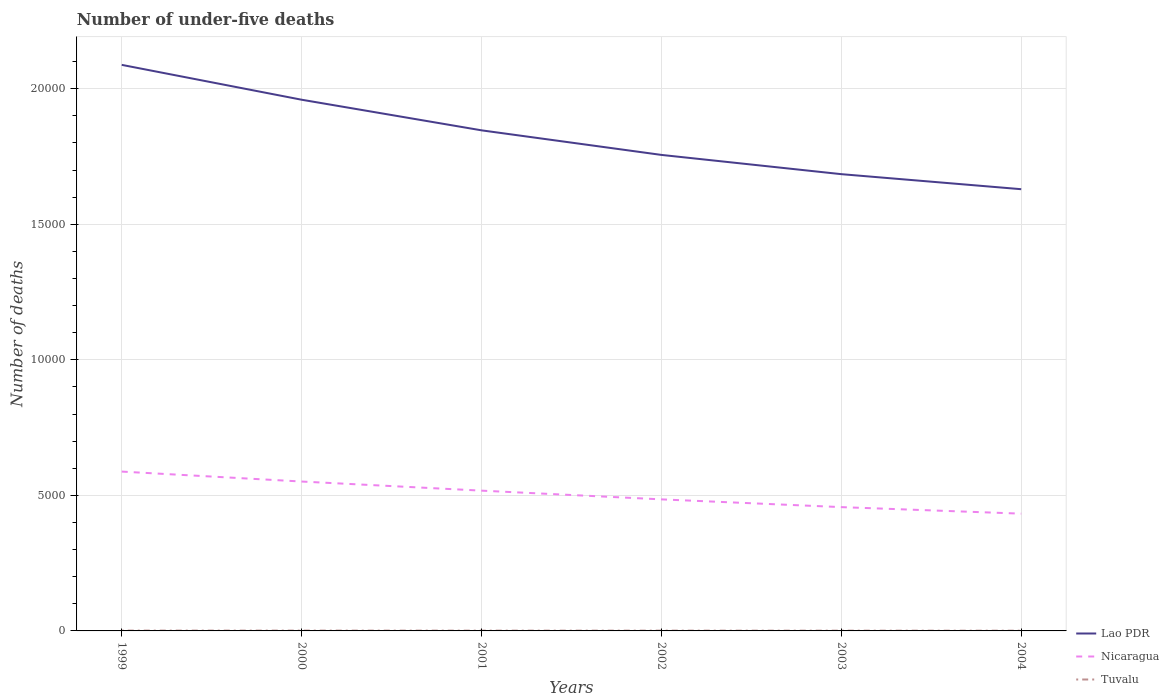Is the number of lines equal to the number of legend labels?
Provide a short and direct response. Yes. Across all years, what is the maximum number of under-five deaths in Lao PDR?
Keep it short and to the point. 1.63e+04. In which year was the number of under-five deaths in Nicaragua maximum?
Make the answer very short. 2004. What is the total number of under-five deaths in Lao PDR in the graph?
Offer a very short reply. 3322. Is the number of under-five deaths in Tuvalu strictly greater than the number of under-five deaths in Lao PDR over the years?
Your answer should be very brief. Yes. How many years are there in the graph?
Keep it short and to the point. 6. What is the difference between two consecutive major ticks on the Y-axis?
Give a very brief answer. 5000. Are the values on the major ticks of Y-axis written in scientific E-notation?
Your response must be concise. No. Does the graph contain any zero values?
Ensure brevity in your answer.  No. How many legend labels are there?
Your answer should be very brief. 3. What is the title of the graph?
Your answer should be very brief. Number of under-five deaths. What is the label or title of the X-axis?
Offer a very short reply. Years. What is the label or title of the Y-axis?
Make the answer very short. Number of deaths. What is the Number of deaths of Lao PDR in 1999?
Provide a short and direct response. 2.09e+04. What is the Number of deaths in Nicaragua in 1999?
Ensure brevity in your answer.  5878. What is the Number of deaths of Tuvalu in 1999?
Provide a succinct answer. 12. What is the Number of deaths in Lao PDR in 2000?
Your response must be concise. 1.96e+04. What is the Number of deaths in Nicaragua in 2000?
Offer a terse response. 5511. What is the Number of deaths of Lao PDR in 2001?
Offer a terse response. 1.85e+04. What is the Number of deaths of Nicaragua in 2001?
Your answer should be very brief. 5175. What is the Number of deaths in Lao PDR in 2002?
Provide a short and direct response. 1.76e+04. What is the Number of deaths in Nicaragua in 2002?
Provide a succinct answer. 4853. What is the Number of deaths of Tuvalu in 2002?
Provide a short and direct response. 11. What is the Number of deaths of Lao PDR in 2003?
Your answer should be compact. 1.68e+04. What is the Number of deaths of Nicaragua in 2003?
Make the answer very short. 4567. What is the Number of deaths of Lao PDR in 2004?
Your response must be concise. 1.63e+04. What is the Number of deaths of Nicaragua in 2004?
Your response must be concise. 4326. What is the Number of deaths of Tuvalu in 2004?
Provide a short and direct response. 9. Across all years, what is the maximum Number of deaths in Lao PDR?
Your answer should be compact. 2.09e+04. Across all years, what is the maximum Number of deaths in Nicaragua?
Your answer should be very brief. 5878. Across all years, what is the maximum Number of deaths of Tuvalu?
Provide a succinct answer. 12. Across all years, what is the minimum Number of deaths of Lao PDR?
Your response must be concise. 1.63e+04. Across all years, what is the minimum Number of deaths in Nicaragua?
Provide a succinct answer. 4326. What is the total Number of deaths of Lao PDR in the graph?
Make the answer very short. 1.10e+05. What is the total Number of deaths in Nicaragua in the graph?
Provide a short and direct response. 3.03e+04. What is the total Number of deaths in Tuvalu in the graph?
Your answer should be very brief. 65. What is the difference between the Number of deaths of Lao PDR in 1999 and that in 2000?
Provide a short and direct response. 1286. What is the difference between the Number of deaths of Nicaragua in 1999 and that in 2000?
Your answer should be very brief. 367. What is the difference between the Number of deaths in Tuvalu in 1999 and that in 2000?
Provide a succinct answer. 0. What is the difference between the Number of deaths in Lao PDR in 1999 and that in 2001?
Give a very brief answer. 2415. What is the difference between the Number of deaths in Nicaragua in 1999 and that in 2001?
Your answer should be compact. 703. What is the difference between the Number of deaths of Tuvalu in 1999 and that in 2001?
Ensure brevity in your answer.  1. What is the difference between the Number of deaths in Lao PDR in 1999 and that in 2002?
Provide a succinct answer. 3322. What is the difference between the Number of deaths in Nicaragua in 1999 and that in 2002?
Give a very brief answer. 1025. What is the difference between the Number of deaths in Lao PDR in 1999 and that in 2003?
Offer a very short reply. 4032. What is the difference between the Number of deaths of Nicaragua in 1999 and that in 2003?
Your answer should be compact. 1311. What is the difference between the Number of deaths of Lao PDR in 1999 and that in 2004?
Ensure brevity in your answer.  4587. What is the difference between the Number of deaths in Nicaragua in 1999 and that in 2004?
Make the answer very short. 1552. What is the difference between the Number of deaths in Lao PDR in 2000 and that in 2001?
Your answer should be compact. 1129. What is the difference between the Number of deaths of Nicaragua in 2000 and that in 2001?
Make the answer very short. 336. What is the difference between the Number of deaths in Tuvalu in 2000 and that in 2001?
Your response must be concise. 1. What is the difference between the Number of deaths of Lao PDR in 2000 and that in 2002?
Offer a very short reply. 2036. What is the difference between the Number of deaths of Nicaragua in 2000 and that in 2002?
Your answer should be compact. 658. What is the difference between the Number of deaths in Lao PDR in 2000 and that in 2003?
Provide a succinct answer. 2746. What is the difference between the Number of deaths in Nicaragua in 2000 and that in 2003?
Keep it short and to the point. 944. What is the difference between the Number of deaths of Lao PDR in 2000 and that in 2004?
Your response must be concise. 3301. What is the difference between the Number of deaths in Nicaragua in 2000 and that in 2004?
Ensure brevity in your answer.  1185. What is the difference between the Number of deaths in Tuvalu in 2000 and that in 2004?
Keep it short and to the point. 3. What is the difference between the Number of deaths in Lao PDR in 2001 and that in 2002?
Your answer should be very brief. 907. What is the difference between the Number of deaths in Nicaragua in 2001 and that in 2002?
Provide a succinct answer. 322. What is the difference between the Number of deaths in Tuvalu in 2001 and that in 2002?
Provide a short and direct response. 0. What is the difference between the Number of deaths in Lao PDR in 2001 and that in 2003?
Offer a very short reply. 1617. What is the difference between the Number of deaths in Nicaragua in 2001 and that in 2003?
Your answer should be very brief. 608. What is the difference between the Number of deaths in Tuvalu in 2001 and that in 2003?
Ensure brevity in your answer.  1. What is the difference between the Number of deaths in Lao PDR in 2001 and that in 2004?
Keep it short and to the point. 2172. What is the difference between the Number of deaths in Nicaragua in 2001 and that in 2004?
Provide a short and direct response. 849. What is the difference between the Number of deaths in Tuvalu in 2001 and that in 2004?
Your response must be concise. 2. What is the difference between the Number of deaths in Lao PDR in 2002 and that in 2003?
Make the answer very short. 710. What is the difference between the Number of deaths of Nicaragua in 2002 and that in 2003?
Keep it short and to the point. 286. What is the difference between the Number of deaths of Tuvalu in 2002 and that in 2003?
Make the answer very short. 1. What is the difference between the Number of deaths in Lao PDR in 2002 and that in 2004?
Provide a short and direct response. 1265. What is the difference between the Number of deaths of Nicaragua in 2002 and that in 2004?
Keep it short and to the point. 527. What is the difference between the Number of deaths of Tuvalu in 2002 and that in 2004?
Your answer should be very brief. 2. What is the difference between the Number of deaths of Lao PDR in 2003 and that in 2004?
Your answer should be compact. 555. What is the difference between the Number of deaths in Nicaragua in 2003 and that in 2004?
Provide a succinct answer. 241. What is the difference between the Number of deaths in Tuvalu in 2003 and that in 2004?
Offer a terse response. 1. What is the difference between the Number of deaths of Lao PDR in 1999 and the Number of deaths of Nicaragua in 2000?
Your response must be concise. 1.54e+04. What is the difference between the Number of deaths in Lao PDR in 1999 and the Number of deaths in Tuvalu in 2000?
Offer a terse response. 2.09e+04. What is the difference between the Number of deaths of Nicaragua in 1999 and the Number of deaths of Tuvalu in 2000?
Your answer should be compact. 5866. What is the difference between the Number of deaths in Lao PDR in 1999 and the Number of deaths in Nicaragua in 2001?
Your response must be concise. 1.57e+04. What is the difference between the Number of deaths in Lao PDR in 1999 and the Number of deaths in Tuvalu in 2001?
Provide a short and direct response. 2.09e+04. What is the difference between the Number of deaths of Nicaragua in 1999 and the Number of deaths of Tuvalu in 2001?
Your answer should be compact. 5867. What is the difference between the Number of deaths of Lao PDR in 1999 and the Number of deaths of Nicaragua in 2002?
Provide a succinct answer. 1.60e+04. What is the difference between the Number of deaths of Lao PDR in 1999 and the Number of deaths of Tuvalu in 2002?
Offer a very short reply. 2.09e+04. What is the difference between the Number of deaths of Nicaragua in 1999 and the Number of deaths of Tuvalu in 2002?
Your answer should be very brief. 5867. What is the difference between the Number of deaths in Lao PDR in 1999 and the Number of deaths in Nicaragua in 2003?
Provide a succinct answer. 1.63e+04. What is the difference between the Number of deaths in Lao PDR in 1999 and the Number of deaths in Tuvalu in 2003?
Offer a very short reply. 2.09e+04. What is the difference between the Number of deaths of Nicaragua in 1999 and the Number of deaths of Tuvalu in 2003?
Offer a very short reply. 5868. What is the difference between the Number of deaths in Lao PDR in 1999 and the Number of deaths in Nicaragua in 2004?
Provide a short and direct response. 1.66e+04. What is the difference between the Number of deaths in Lao PDR in 1999 and the Number of deaths in Tuvalu in 2004?
Offer a terse response. 2.09e+04. What is the difference between the Number of deaths in Nicaragua in 1999 and the Number of deaths in Tuvalu in 2004?
Your answer should be very brief. 5869. What is the difference between the Number of deaths in Lao PDR in 2000 and the Number of deaths in Nicaragua in 2001?
Your response must be concise. 1.44e+04. What is the difference between the Number of deaths in Lao PDR in 2000 and the Number of deaths in Tuvalu in 2001?
Keep it short and to the point. 1.96e+04. What is the difference between the Number of deaths of Nicaragua in 2000 and the Number of deaths of Tuvalu in 2001?
Your answer should be compact. 5500. What is the difference between the Number of deaths of Lao PDR in 2000 and the Number of deaths of Nicaragua in 2002?
Ensure brevity in your answer.  1.47e+04. What is the difference between the Number of deaths in Lao PDR in 2000 and the Number of deaths in Tuvalu in 2002?
Give a very brief answer. 1.96e+04. What is the difference between the Number of deaths in Nicaragua in 2000 and the Number of deaths in Tuvalu in 2002?
Offer a terse response. 5500. What is the difference between the Number of deaths in Lao PDR in 2000 and the Number of deaths in Nicaragua in 2003?
Keep it short and to the point. 1.50e+04. What is the difference between the Number of deaths in Lao PDR in 2000 and the Number of deaths in Tuvalu in 2003?
Offer a very short reply. 1.96e+04. What is the difference between the Number of deaths in Nicaragua in 2000 and the Number of deaths in Tuvalu in 2003?
Your answer should be very brief. 5501. What is the difference between the Number of deaths of Lao PDR in 2000 and the Number of deaths of Nicaragua in 2004?
Ensure brevity in your answer.  1.53e+04. What is the difference between the Number of deaths in Lao PDR in 2000 and the Number of deaths in Tuvalu in 2004?
Make the answer very short. 1.96e+04. What is the difference between the Number of deaths in Nicaragua in 2000 and the Number of deaths in Tuvalu in 2004?
Offer a terse response. 5502. What is the difference between the Number of deaths of Lao PDR in 2001 and the Number of deaths of Nicaragua in 2002?
Provide a succinct answer. 1.36e+04. What is the difference between the Number of deaths of Lao PDR in 2001 and the Number of deaths of Tuvalu in 2002?
Offer a very short reply. 1.85e+04. What is the difference between the Number of deaths in Nicaragua in 2001 and the Number of deaths in Tuvalu in 2002?
Offer a terse response. 5164. What is the difference between the Number of deaths of Lao PDR in 2001 and the Number of deaths of Nicaragua in 2003?
Offer a terse response. 1.39e+04. What is the difference between the Number of deaths of Lao PDR in 2001 and the Number of deaths of Tuvalu in 2003?
Your answer should be very brief. 1.85e+04. What is the difference between the Number of deaths of Nicaragua in 2001 and the Number of deaths of Tuvalu in 2003?
Your answer should be very brief. 5165. What is the difference between the Number of deaths in Lao PDR in 2001 and the Number of deaths in Nicaragua in 2004?
Offer a terse response. 1.41e+04. What is the difference between the Number of deaths in Lao PDR in 2001 and the Number of deaths in Tuvalu in 2004?
Give a very brief answer. 1.85e+04. What is the difference between the Number of deaths in Nicaragua in 2001 and the Number of deaths in Tuvalu in 2004?
Ensure brevity in your answer.  5166. What is the difference between the Number of deaths of Lao PDR in 2002 and the Number of deaths of Nicaragua in 2003?
Your response must be concise. 1.30e+04. What is the difference between the Number of deaths of Lao PDR in 2002 and the Number of deaths of Tuvalu in 2003?
Make the answer very short. 1.76e+04. What is the difference between the Number of deaths of Nicaragua in 2002 and the Number of deaths of Tuvalu in 2003?
Provide a succinct answer. 4843. What is the difference between the Number of deaths in Lao PDR in 2002 and the Number of deaths in Nicaragua in 2004?
Your answer should be very brief. 1.32e+04. What is the difference between the Number of deaths of Lao PDR in 2002 and the Number of deaths of Tuvalu in 2004?
Make the answer very short. 1.76e+04. What is the difference between the Number of deaths in Nicaragua in 2002 and the Number of deaths in Tuvalu in 2004?
Your response must be concise. 4844. What is the difference between the Number of deaths in Lao PDR in 2003 and the Number of deaths in Nicaragua in 2004?
Provide a short and direct response. 1.25e+04. What is the difference between the Number of deaths of Lao PDR in 2003 and the Number of deaths of Tuvalu in 2004?
Give a very brief answer. 1.68e+04. What is the difference between the Number of deaths in Nicaragua in 2003 and the Number of deaths in Tuvalu in 2004?
Offer a very short reply. 4558. What is the average Number of deaths in Lao PDR per year?
Your response must be concise. 1.83e+04. What is the average Number of deaths of Nicaragua per year?
Make the answer very short. 5051.67. What is the average Number of deaths of Tuvalu per year?
Offer a very short reply. 10.83. In the year 1999, what is the difference between the Number of deaths in Lao PDR and Number of deaths in Nicaragua?
Your answer should be compact. 1.50e+04. In the year 1999, what is the difference between the Number of deaths in Lao PDR and Number of deaths in Tuvalu?
Your answer should be very brief. 2.09e+04. In the year 1999, what is the difference between the Number of deaths in Nicaragua and Number of deaths in Tuvalu?
Make the answer very short. 5866. In the year 2000, what is the difference between the Number of deaths in Lao PDR and Number of deaths in Nicaragua?
Offer a terse response. 1.41e+04. In the year 2000, what is the difference between the Number of deaths in Lao PDR and Number of deaths in Tuvalu?
Make the answer very short. 1.96e+04. In the year 2000, what is the difference between the Number of deaths of Nicaragua and Number of deaths of Tuvalu?
Provide a short and direct response. 5499. In the year 2001, what is the difference between the Number of deaths of Lao PDR and Number of deaths of Nicaragua?
Ensure brevity in your answer.  1.33e+04. In the year 2001, what is the difference between the Number of deaths of Lao PDR and Number of deaths of Tuvalu?
Ensure brevity in your answer.  1.85e+04. In the year 2001, what is the difference between the Number of deaths in Nicaragua and Number of deaths in Tuvalu?
Provide a succinct answer. 5164. In the year 2002, what is the difference between the Number of deaths of Lao PDR and Number of deaths of Nicaragua?
Your answer should be compact. 1.27e+04. In the year 2002, what is the difference between the Number of deaths in Lao PDR and Number of deaths in Tuvalu?
Make the answer very short. 1.75e+04. In the year 2002, what is the difference between the Number of deaths in Nicaragua and Number of deaths in Tuvalu?
Offer a terse response. 4842. In the year 2003, what is the difference between the Number of deaths in Lao PDR and Number of deaths in Nicaragua?
Your answer should be compact. 1.23e+04. In the year 2003, what is the difference between the Number of deaths in Lao PDR and Number of deaths in Tuvalu?
Give a very brief answer. 1.68e+04. In the year 2003, what is the difference between the Number of deaths of Nicaragua and Number of deaths of Tuvalu?
Your answer should be very brief. 4557. In the year 2004, what is the difference between the Number of deaths in Lao PDR and Number of deaths in Nicaragua?
Your answer should be very brief. 1.20e+04. In the year 2004, what is the difference between the Number of deaths of Lao PDR and Number of deaths of Tuvalu?
Keep it short and to the point. 1.63e+04. In the year 2004, what is the difference between the Number of deaths of Nicaragua and Number of deaths of Tuvalu?
Make the answer very short. 4317. What is the ratio of the Number of deaths in Lao PDR in 1999 to that in 2000?
Offer a very short reply. 1.07. What is the ratio of the Number of deaths of Nicaragua in 1999 to that in 2000?
Your answer should be very brief. 1.07. What is the ratio of the Number of deaths in Lao PDR in 1999 to that in 2001?
Provide a short and direct response. 1.13. What is the ratio of the Number of deaths in Nicaragua in 1999 to that in 2001?
Offer a terse response. 1.14. What is the ratio of the Number of deaths in Tuvalu in 1999 to that in 2001?
Keep it short and to the point. 1.09. What is the ratio of the Number of deaths of Lao PDR in 1999 to that in 2002?
Your answer should be very brief. 1.19. What is the ratio of the Number of deaths of Nicaragua in 1999 to that in 2002?
Offer a very short reply. 1.21. What is the ratio of the Number of deaths in Lao PDR in 1999 to that in 2003?
Keep it short and to the point. 1.24. What is the ratio of the Number of deaths of Nicaragua in 1999 to that in 2003?
Keep it short and to the point. 1.29. What is the ratio of the Number of deaths in Tuvalu in 1999 to that in 2003?
Offer a terse response. 1.2. What is the ratio of the Number of deaths in Lao PDR in 1999 to that in 2004?
Your answer should be very brief. 1.28. What is the ratio of the Number of deaths of Nicaragua in 1999 to that in 2004?
Your answer should be compact. 1.36. What is the ratio of the Number of deaths in Lao PDR in 2000 to that in 2001?
Provide a succinct answer. 1.06. What is the ratio of the Number of deaths of Nicaragua in 2000 to that in 2001?
Offer a very short reply. 1.06. What is the ratio of the Number of deaths in Tuvalu in 2000 to that in 2001?
Ensure brevity in your answer.  1.09. What is the ratio of the Number of deaths of Lao PDR in 2000 to that in 2002?
Keep it short and to the point. 1.12. What is the ratio of the Number of deaths of Nicaragua in 2000 to that in 2002?
Your answer should be very brief. 1.14. What is the ratio of the Number of deaths of Lao PDR in 2000 to that in 2003?
Offer a very short reply. 1.16. What is the ratio of the Number of deaths in Nicaragua in 2000 to that in 2003?
Your answer should be very brief. 1.21. What is the ratio of the Number of deaths of Tuvalu in 2000 to that in 2003?
Provide a short and direct response. 1.2. What is the ratio of the Number of deaths of Lao PDR in 2000 to that in 2004?
Ensure brevity in your answer.  1.2. What is the ratio of the Number of deaths of Nicaragua in 2000 to that in 2004?
Offer a very short reply. 1.27. What is the ratio of the Number of deaths in Tuvalu in 2000 to that in 2004?
Your answer should be compact. 1.33. What is the ratio of the Number of deaths of Lao PDR in 2001 to that in 2002?
Keep it short and to the point. 1.05. What is the ratio of the Number of deaths in Nicaragua in 2001 to that in 2002?
Your response must be concise. 1.07. What is the ratio of the Number of deaths in Lao PDR in 2001 to that in 2003?
Give a very brief answer. 1.1. What is the ratio of the Number of deaths of Nicaragua in 2001 to that in 2003?
Keep it short and to the point. 1.13. What is the ratio of the Number of deaths in Lao PDR in 2001 to that in 2004?
Offer a very short reply. 1.13. What is the ratio of the Number of deaths of Nicaragua in 2001 to that in 2004?
Your answer should be compact. 1.2. What is the ratio of the Number of deaths in Tuvalu in 2001 to that in 2004?
Offer a terse response. 1.22. What is the ratio of the Number of deaths in Lao PDR in 2002 to that in 2003?
Keep it short and to the point. 1.04. What is the ratio of the Number of deaths in Nicaragua in 2002 to that in 2003?
Give a very brief answer. 1.06. What is the ratio of the Number of deaths of Tuvalu in 2002 to that in 2003?
Your answer should be very brief. 1.1. What is the ratio of the Number of deaths in Lao PDR in 2002 to that in 2004?
Your answer should be very brief. 1.08. What is the ratio of the Number of deaths in Nicaragua in 2002 to that in 2004?
Provide a short and direct response. 1.12. What is the ratio of the Number of deaths of Tuvalu in 2002 to that in 2004?
Give a very brief answer. 1.22. What is the ratio of the Number of deaths in Lao PDR in 2003 to that in 2004?
Your answer should be compact. 1.03. What is the ratio of the Number of deaths in Nicaragua in 2003 to that in 2004?
Provide a succinct answer. 1.06. What is the difference between the highest and the second highest Number of deaths in Lao PDR?
Provide a succinct answer. 1286. What is the difference between the highest and the second highest Number of deaths of Nicaragua?
Offer a terse response. 367. What is the difference between the highest and the second highest Number of deaths of Tuvalu?
Your response must be concise. 0. What is the difference between the highest and the lowest Number of deaths in Lao PDR?
Offer a very short reply. 4587. What is the difference between the highest and the lowest Number of deaths in Nicaragua?
Provide a short and direct response. 1552. What is the difference between the highest and the lowest Number of deaths in Tuvalu?
Ensure brevity in your answer.  3. 